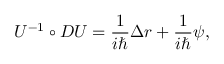Convert formula to latex. <formula><loc_0><loc_0><loc_500><loc_500>U ^ { - 1 } \circ D U = \frac { 1 } i } \Delta r + \frac { 1 } i } \psi ,</formula> 